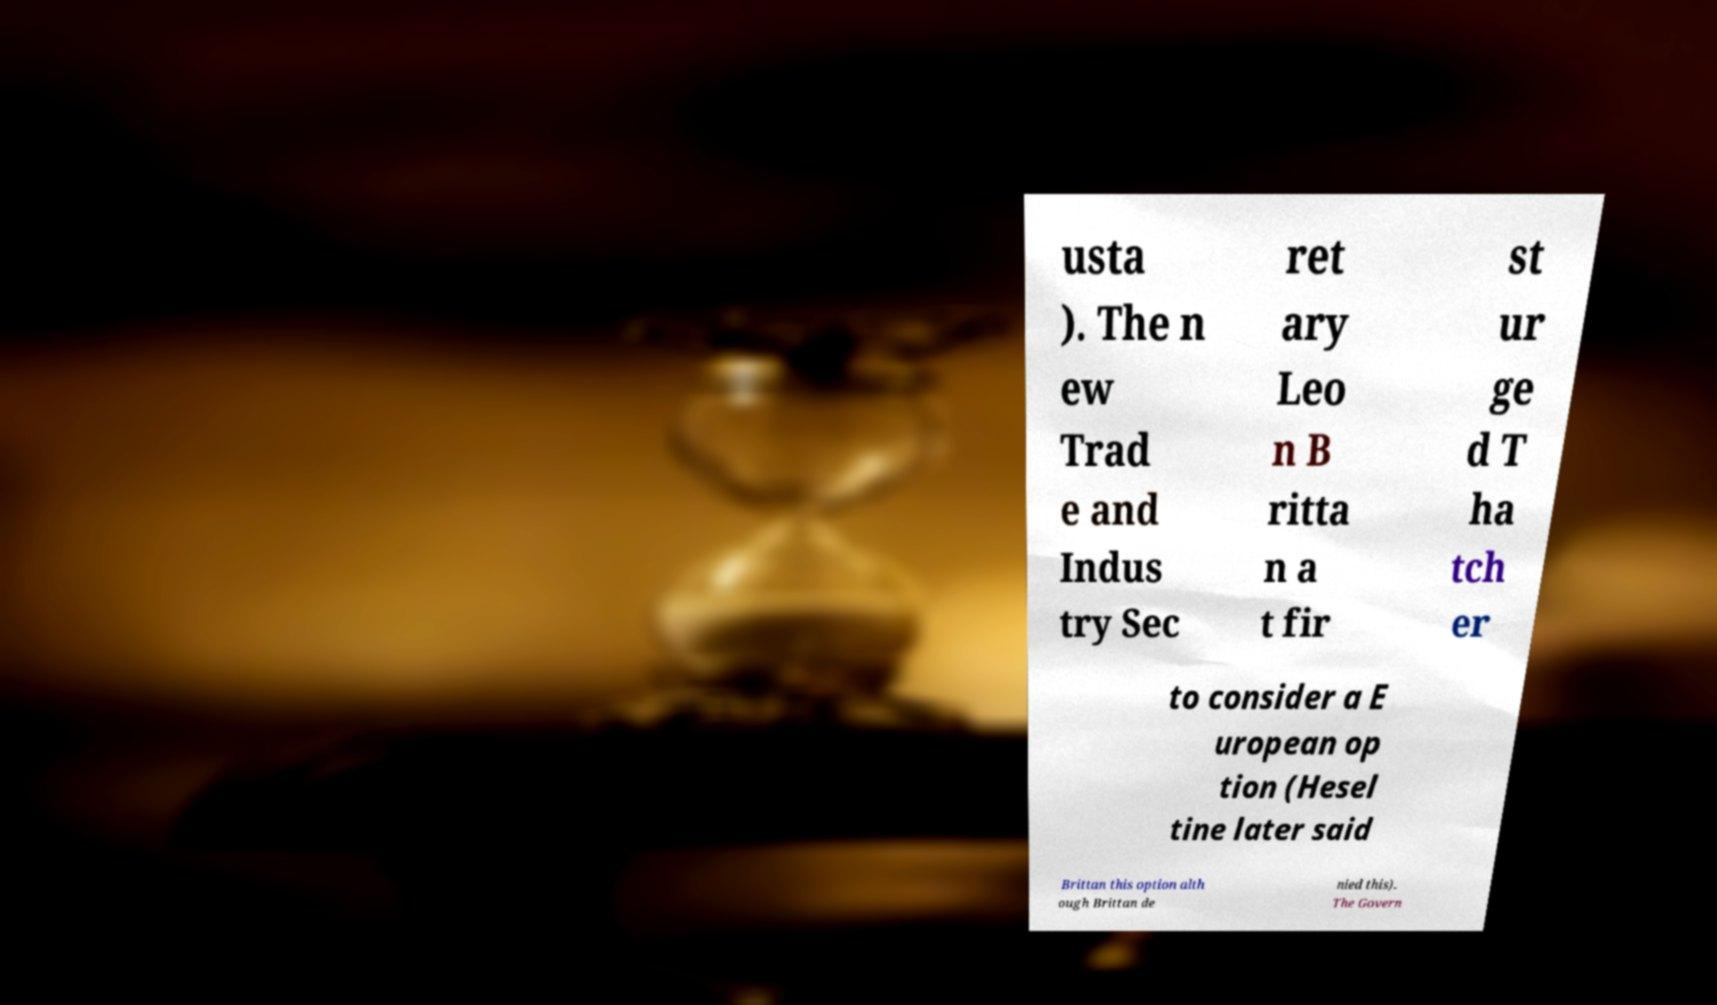I need the written content from this picture converted into text. Can you do that? usta ). The n ew Trad e and Indus try Sec ret ary Leo n B ritta n a t fir st ur ge d T ha tch er to consider a E uropean op tion (Hesel tine later said Brittan this option alth ough Brittan de nied this). The Govern 